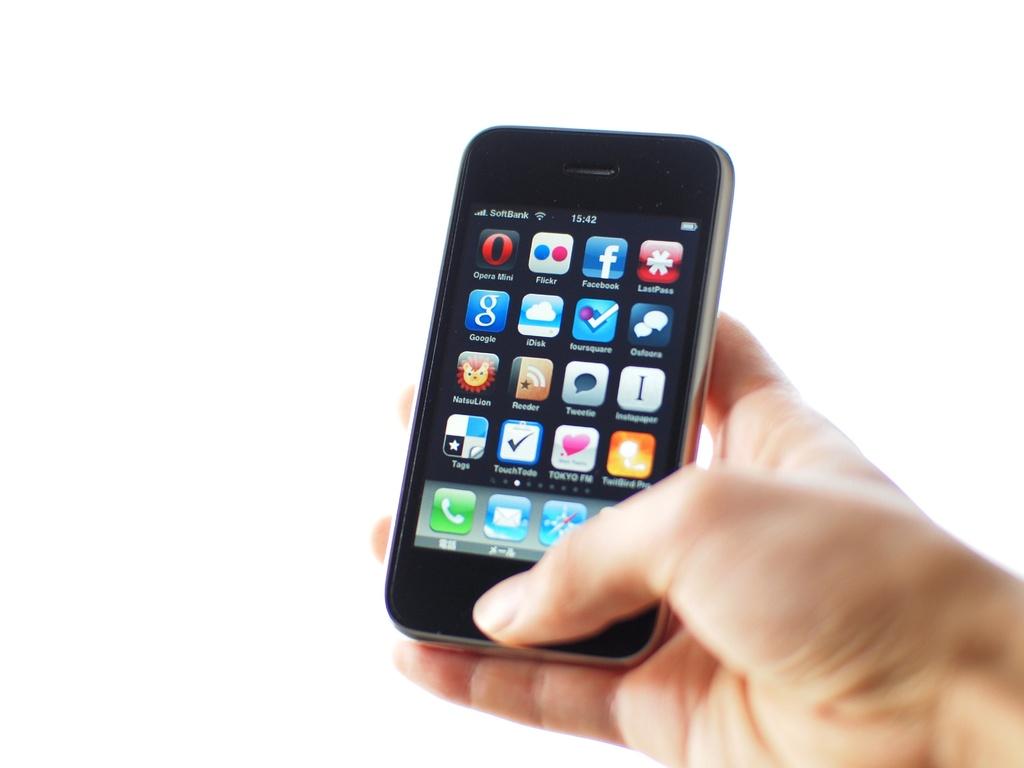What is the time displayed on the phone?
Your response must be concise. 15:42. What does the app on the bottom left corner say?
Make the answer very short. Tags. 